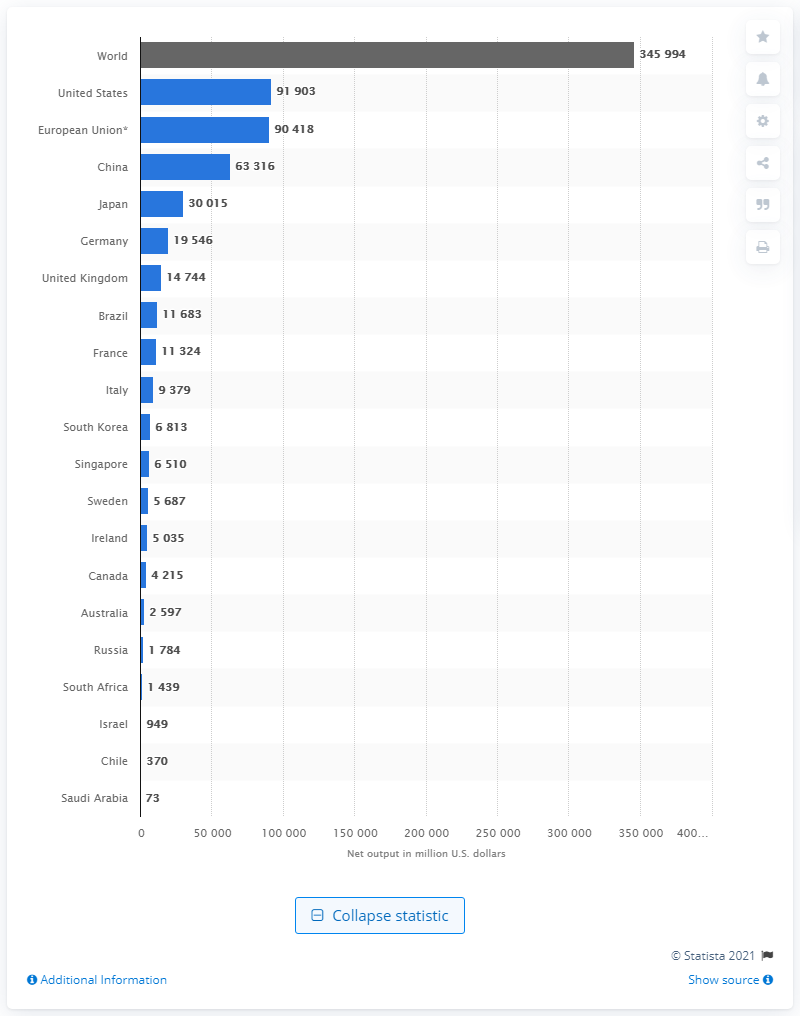Mention a couple of crucial points in this snapshot. The global production of pharmaceuticals in 2010 was approximately 345994... In 2010, the largest output of pharmaceuticals in the United States was approximately 91,903 metric tons. 